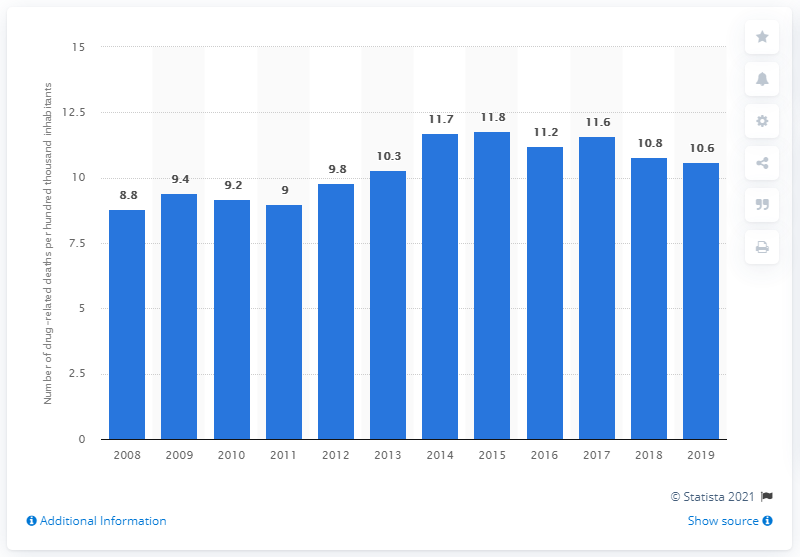Point out several critical features in this image. In 2019, there were approximately 10.6 drug-related deaths per hundred thousand inhabitants in Sweden. 